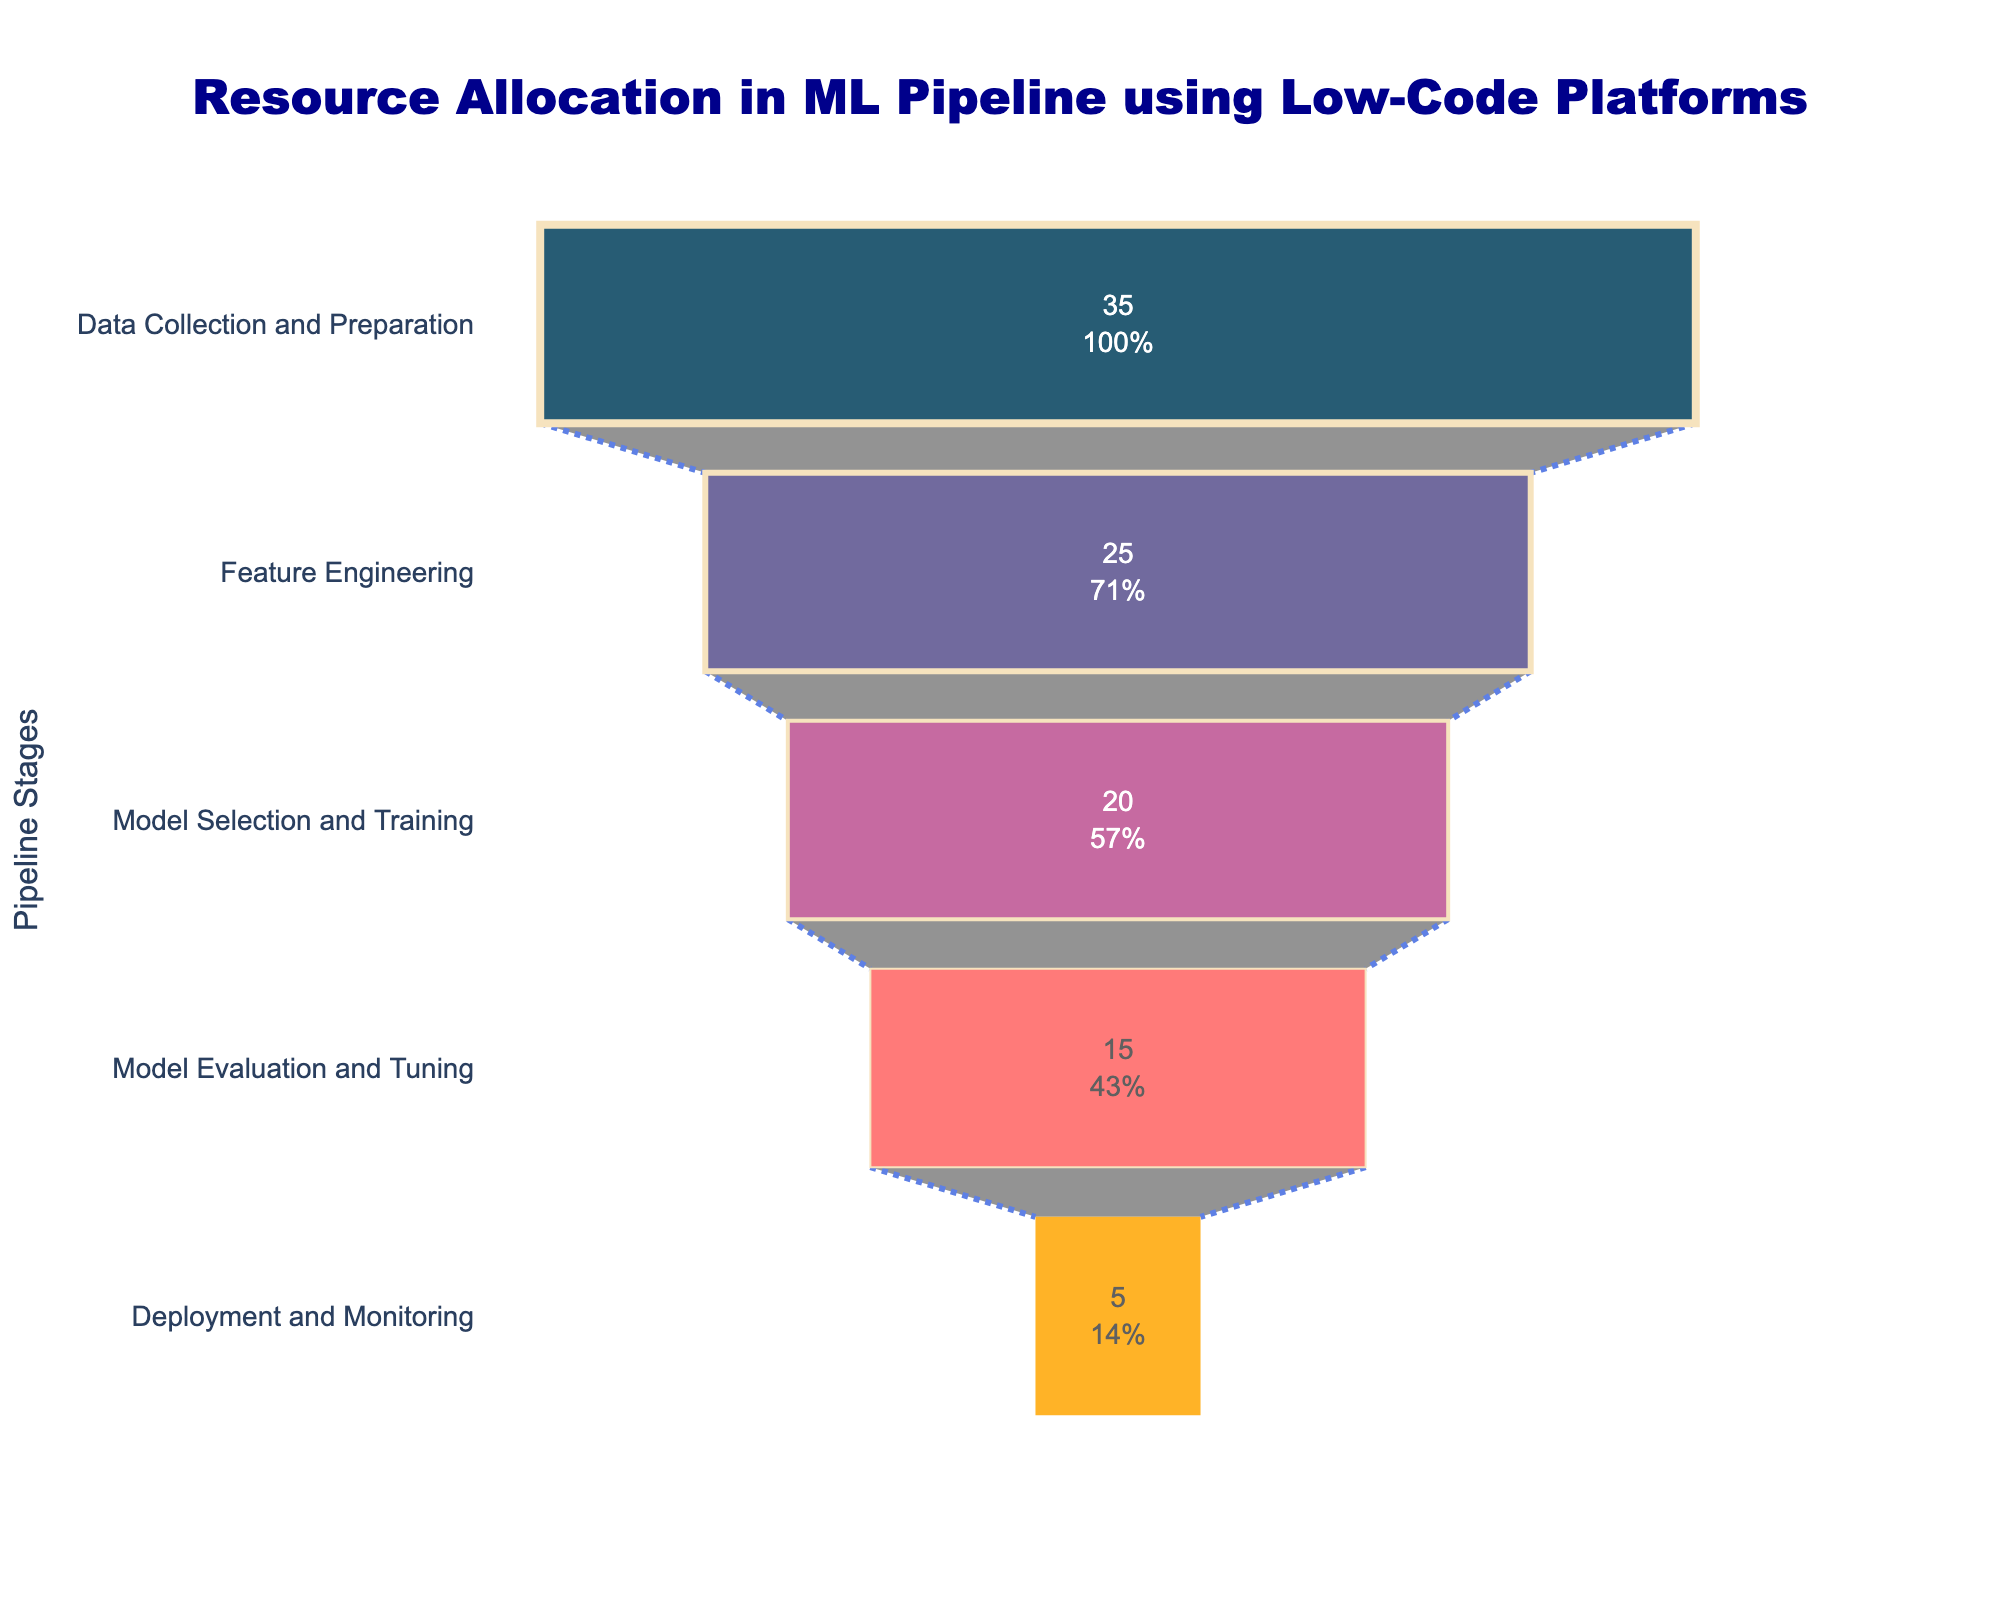What is the title of the figure? The title is located at the top of the figure. It is placed centrally, written in dark blue, and uses a large, bold font.
Answer: "Resource Allocation in ML Pipeline using Low-Code Platforms" How many stages are displayed in the funnel chart? Count the number of distinct stages listed on the y-axis or within the funnel segments. Each segment represents a stage.
Answer: 5 Which stage has the highest percentage of resources allocated? Look at the top segment of the funnel, which represents the stage with the highest percentage of resources.
Answer: Data Collection and Preparation What is the combined percentage of resources allocated to Model Selection and Training and Model Evaluation and Tuning? Add the resources allocated to both stages. Model Selection and Training is 20%, and Model Evaluation and Tuning is 15%. The sum is 20 + 15.
Answer: 35% Which stages together receive exactly 50% of the resources? To get the stages with a combined 50% allocation, try adding the percentages of different stages: Data Collection and Preparation (35%) + Deployment and Monitoring (5%) + Model Evaluation and Tuning (15%) = 55%, and Model Selection and Training (20%) + Feature Engineering (25%) = 45%. Data Collection and Preparation (35%) + Feature Engineering (25%) = 60%. Only Model Selection and Training (20%) + Model Evaluation and Tuning (15%) = 35%, thus none combined exactly 50%.
Answer: None Which stage receives fewer resources: Deployment and Monitoring or Feature Engineering? Compare the percentages allocated to both stages. Deployment and Monitoring has 5%, while Feature Engineering has 25%.
Answer: Deployment and Monitoring What percentage of resources is allocated to the stages after Data Collection and Preparation? Subtract the percentage allocated to Data Collection and Preparation (35%) from 100%. The remaining stages jointly receive the rest. 100% - 35% = 65%.
Answer: 65% What is the average percentage of resources allocated across all stages? Sum the resources allocated to all stages and divide by the number of stages. (35% + 25% + 20% + 15% + 5%) / 5 = 100% / 5 = 20%.
Answer: 20% How does the resource allocation to Deployment and Monitoring compare to Model Evaluation and Tuning? Compare the percentages: Deployment and Monitoring has 5%, while Model Evaluation and Tuning has 15%. Model Evaluation and Tuning receives more resources.
Answer: Model Evaluation and Tuning receives more resources 